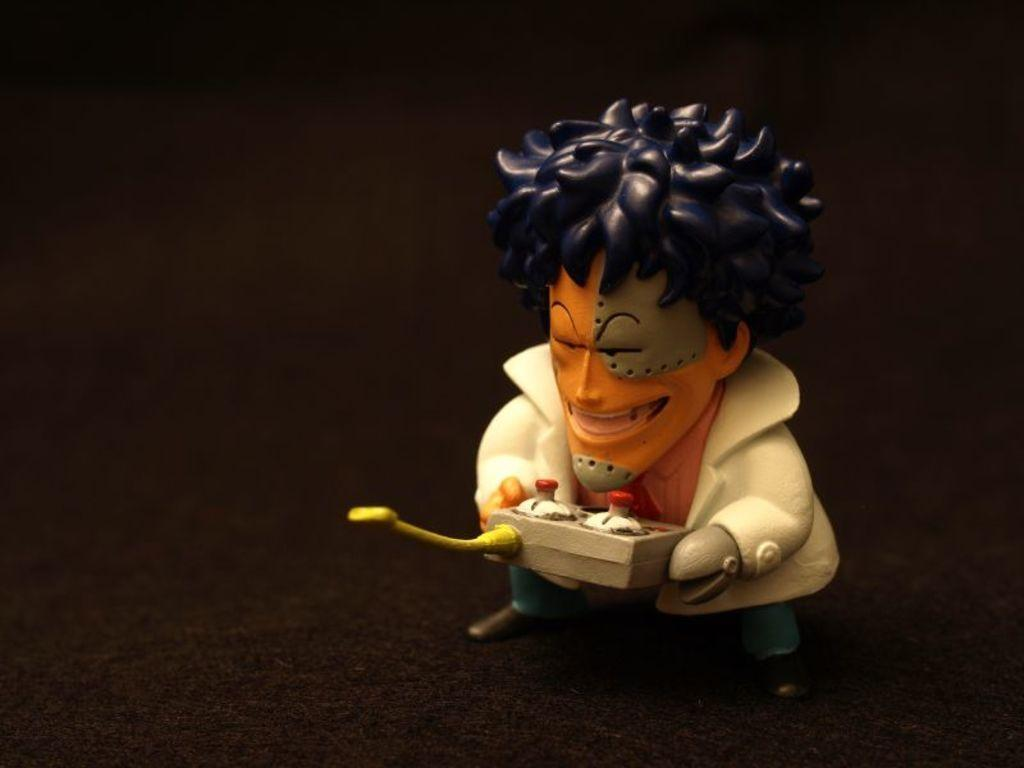What type of toy is present in the image? There is a toy person in the image. What is the toy person wearing? The toy person is wearing a white blazer and an orange shirt. What is the toy person holding? The toy person is holding an object. How would you describe the background of the image? The background of the image is dark. What flavor of ice cream is the toy person eating in the image? There is no ice cream present in the image, so it is not possible to determine the flavor. 